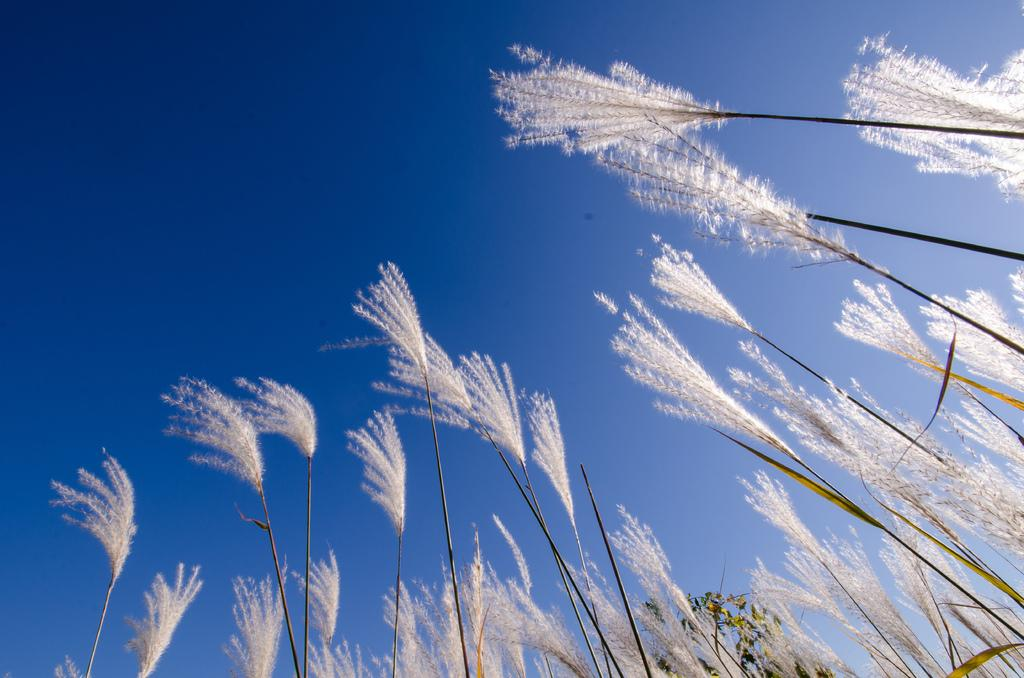What color are the flowers on the plants in the image? The flowers on the plants are white. Can you describe the arrangement of the plants in the image? There is one plant in the foreground with white flowers, and another plant at the back. What is visible at the top of the image? The sky is visible at the top of the image. What type of bone can be seen in the image? There is no bone present in the image; it features plants with white flowers. How much profit can be made from the plants in the image? The image does not provide any information about the profitability of the plants, as it focuses on their appearance and arrangement. 